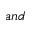<formula> <loc_0><loc_0><loc_500><loc_500>a n d</formula> 